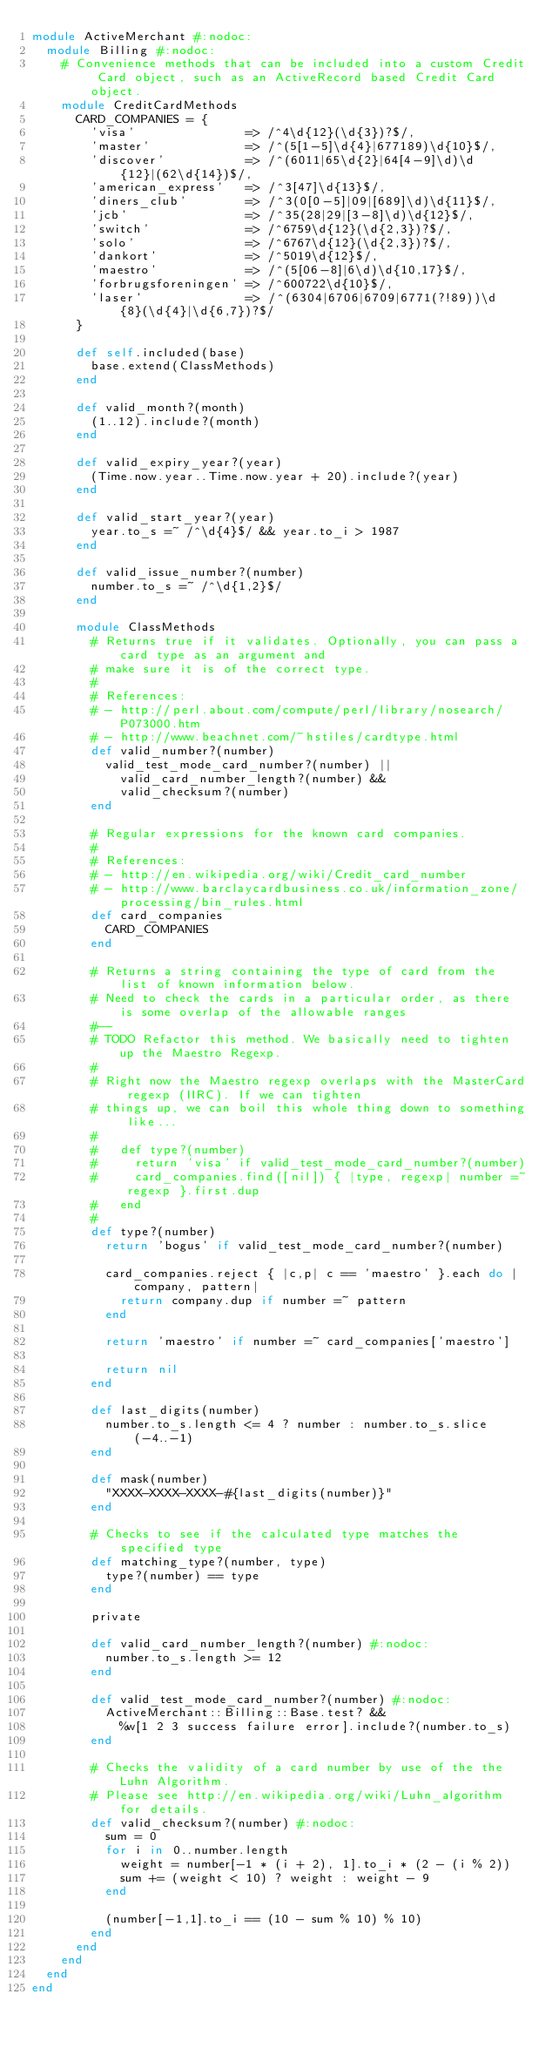<code> <loc_0><loc_0><loc_500><loc_500><_Ruby_>module ActiveMerchant #:nodoc:
  module Billing #:nodoc:
    # Convenience methods that can be included into a custom Credit Card object, such as an ActiveRecord based Credit Card object.
    module CreditCardMethods
      CARD_COMPANIES = { 
        'visa'               => /^4\d{12}(\d{3})?$/,
        'master'             => /^(5[1-5]\d{4}|677189)\d{10}$/,
        'discover'           => /^(6011|65\d{2}|64[4-9]\d)\d{12}|(62\d{14})$/,
        'american_express'   => /^3[47]\d{13}$/,
        'diners_club'        => /^3(0[0-5]|09|[689]\d)\d{11}$/,
        'jcb'                => /^35(28|29|[3-8]\d)\d{12}$/,
        'switch'             => /^6759\d{12}(\d{2,3})?$/,
        'solo'               => /^6767\d{12}(\d{2,3})?$/,
        'dankort'            => /^5019\d{12}$/,
        'maestro'            => /^(5[06-8]|6\d)\d{10,17}$/,
        'forbrugsforeningen' => /^600722\d{10}$/,
        'laser'              => /^(6304|6706|6709|6771(?!89))\d{8}(\d{4}|\d{6,7})?$/
      }
    
      def self.included(base)
        base.extend(ClassMethods)
      end
      
      def valid_month?(month)
        (1..12).include?(month)
      end
      
      def valid_expiry_year?(year)
        (Time.now.year..Time.now.year + 20).include?(year)
      end
      
      def valid_start_year?(year)
        year.to_s =~ /^\d{4}$/ && year.to_i > 1987
      end
      
      def valid_issue_number?(number)
        number.to_s =~ /^\d{1,2}$/
      end
      
      module ClassMethods
        # Returns true if it validates. Optionally, you can pass a card type as an argument and 
        # make sure it is of the correct type.
        #
        # References:
        # - http://perl.about.com/compute/perl/library/nosearch/P073000.htm
        # - http://www.beachnet.com/~hstiles/cardtype.html
        def valid_number?(number)
          valid_test_mode_card_number?(number) || 
            valid_card_number_length?(number) && 
            valid_checksum?(number)
        end
        
        # Regular expressions for the known card companies.
        # 
        # References: 
        # - http://en.wikipedia.org/wiki/Credit_card_number 
        # - http://www.barclaycardbusiness.co.uk/information_zone/processing/bin_rules.html 
        def card_companies
          CARD_COMPANIES
        end
        
        # Returns a string containing the type of card from the list of known information below.
        # Need to check the cards in a particular order, as there is some overlap of the allowable ranges
        #--
        # TODO Refactor this method. We basically need to tighten up the Maestro Regexp. 
        # 
        # Right now the Maestro regexp overlaps with the MasterCard regexp (IIRC). If we can tighten 
        # things up, we can boil this whole thing down to something like... 
        # 
        #   def type?(number)
        #     return 'visa' if valid_test_mode_card_number?(number)
        #     card_companies.find([nil]) { |type, regexp| number =~ regexp }.first.dup
        #   end
        # 
        def type?(number)
          return 'bogus' if valid_test_mode_card_number?(number)

          card_companies.reject { |c,p| c == 'maestro' }.each do |company, pattern|
            return company.dup if number =~ pattern 
          end
          
          return 'maestro' if number =~ card_companies['maestro']

          return nil
        end
        
        def last_digits(number)     
          number.to_s.length <= 4 ? number : number.to_s.slice(-4..-1) 
        end
        
        def mask(number)
          "XXXX-XXXX-XXXX-#{last_digits(number)}"
        end
        
        # Checks to see if the calculated type matches the specified type
        def matching_type?(number, type)
          type?(number) == type
        end
        
        private
        
        def valid_card_number_length?(number) #:nodoc:
          number.to_s.length >= 12
        end
        
        def valid_test_mode_card_number?(number) #:nodoc:
          ActiveMerchant::Billing::Base.test? && 
            %w[1 2 3 success failure error].include?(number.to_s)
        end
        
        # Checks the validity of a card number by use of the the Luhn Algorithm. 
        # Please see http://en.wikipedia.org/wiki/Luhn_algorithm for details.
        def valid_checksum?(number) #:nodoc:
          sum = 0
          for i in 0..number.length
            weight = number[-1 * (i + 2), 1].to_i * (2 - (i % 2))
            sum += (weight < 10) ? weight : weight - 9
          end
          
          (number[-1,1].to_i == (10 - sum % 10) % 10)
        end
      end
    end
  end
end
</code> 